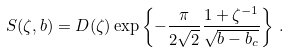Convert formula to latex. <formula><loc_0><loc_0><loc_500><loc_500>S ( \zeta , b ) = D ( \zeta ) \exp \left \{ - \frac { \pi } { 2 \sqrt { 2 } } \frac { 1 + \zeta ^ { - 1 } } { \sqrt { b - b _ { c } } } \right \} \, .</formula> 